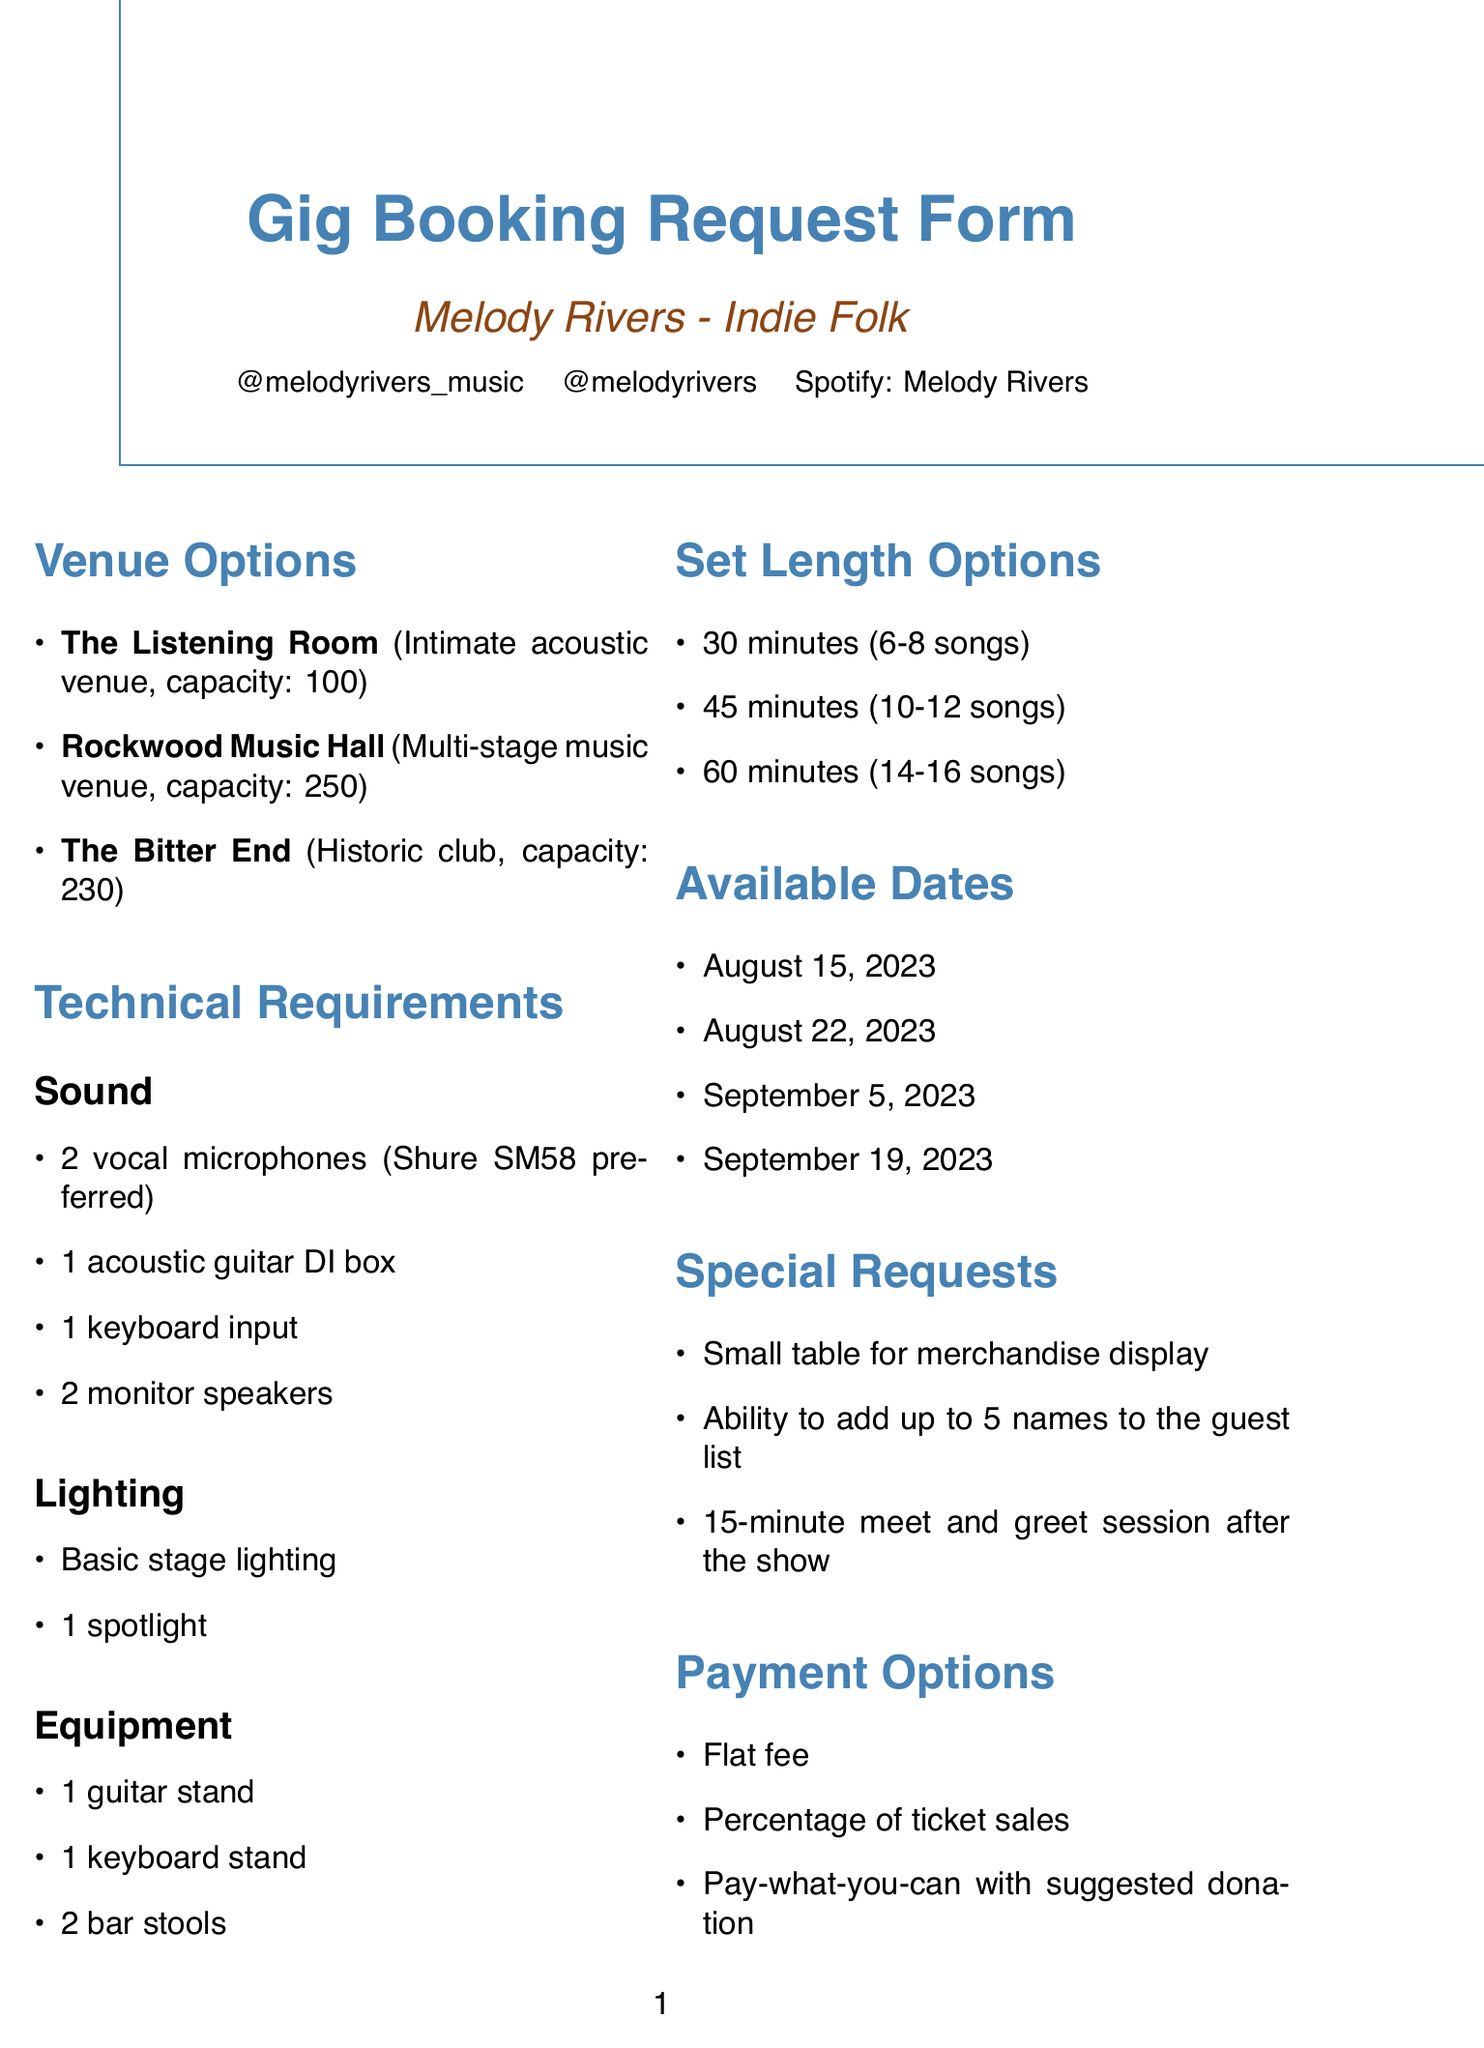What is the artist's name? The artist's name is provided at the beginning of the document.
Answer: Melody Rivers What is the genre of the artist? The genre of the artist is specified right after the artist's name.
Answer: Indie Folk What is the capacity of The Bitter End? The capacity for The Bitter End is listed in the venue details section.
Answer: 230 How many vocal microphones are required? The number of vocal microphones is mentioned in the technical requirements section under sound.
Answer: 2 What is the duration of the longest set length option? The set length options specify durations, and the longest one is identified.
Answer: 60 minutes On what date is the first available gig? The available dates are listed, and the first one is the earliest date.
Answer: August 15, 2023 What special request involves interaction with fans? The special requests section includes various requests, one of which involves fan interaction.
Answer: 15-minute meet and greet session after the show What kind of payment options are mentioned? The payment options are listed in a specific section, outlining the different methods.
Answer: Flat fee, Percentage of ticket sales, Pay-what-you-can with suggested donation What equipment is specifically for the keyboard? The equipment section outlines specific items needed, one of which is for the keyboard.
Answer: 1 keyboard stand 